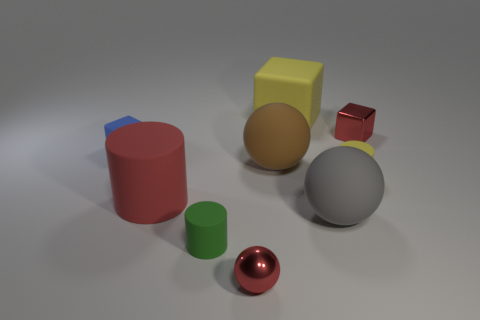Subtract all yellow blocks. How many blocks are left? 2 Subtract all gray balls. How many balls are left? 2 Subtract all cyan blocks. Subtract all brown cylinders. How many blocks are left? 3 Subtract all green cubes. How many cyan cylinders are left? 0 Subtract all red cylinders. Subtract all blue things. How many objects are left? 7 Add 1 small red metallic spheres. How many small red metallic spheres are left? 2 Add 1 blue rubber balls. How many blue rubber balls exist? 1 Subtract 0 green cubes. How many objects are left? 9 Subtract all cylinders. How many objects are left? 6 Subtract 1 balls. How many balls are left? 2 